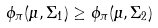<formula> <loc_0><loc_0><loc_500><loc_500>\phi _ { \pi } ( \mu , \Sigma _ { 1 } ) \geq \phi _ { \pi } ( \mu , \Sigma _ { 2 } )</formula> 